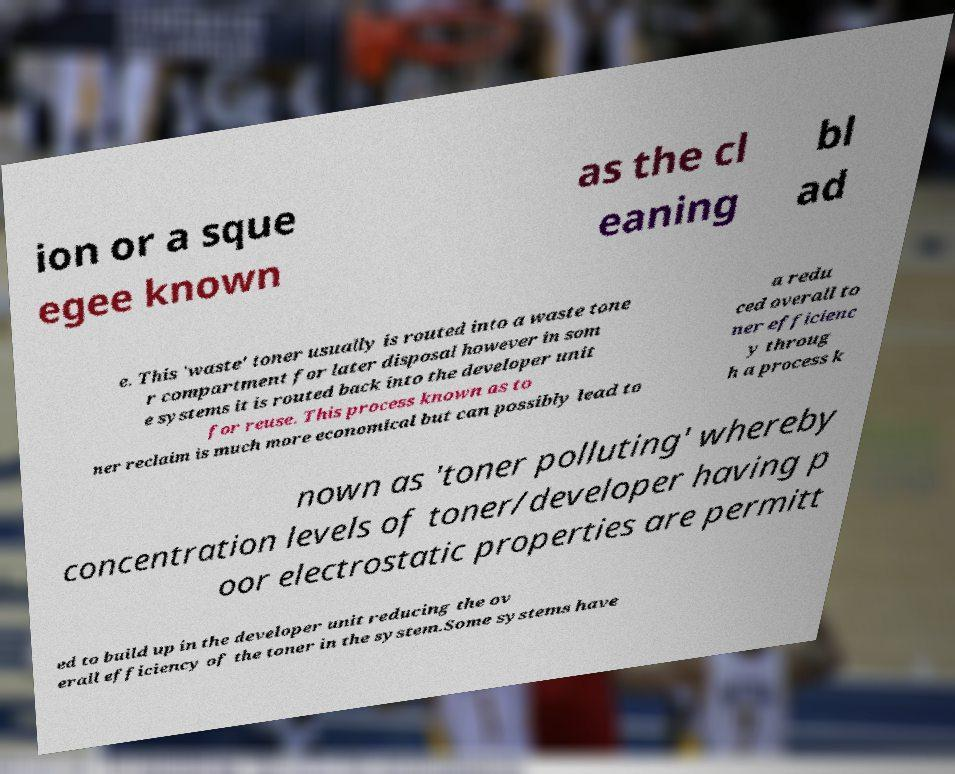Can you accurately transcribe the text from the provided image for me? ion or a sque egee known as the cl eaning bl ad e. This 'waste' toner usually is routed into a waste tone r compartment for later disposal however in som e systems it is routed back into the developer unit for reuse. This process known as to ner reclaim is much more economical but can possibly lead to a redu ced overall to ner efficienc y throug h a process k nown as 'toner polluting' whereby concentration levels of toner/developer having p oor electrostatic properties are permitt ed to build up in the developer unit reducing the ov erall efficiency of the toner in the system.Some systems have 